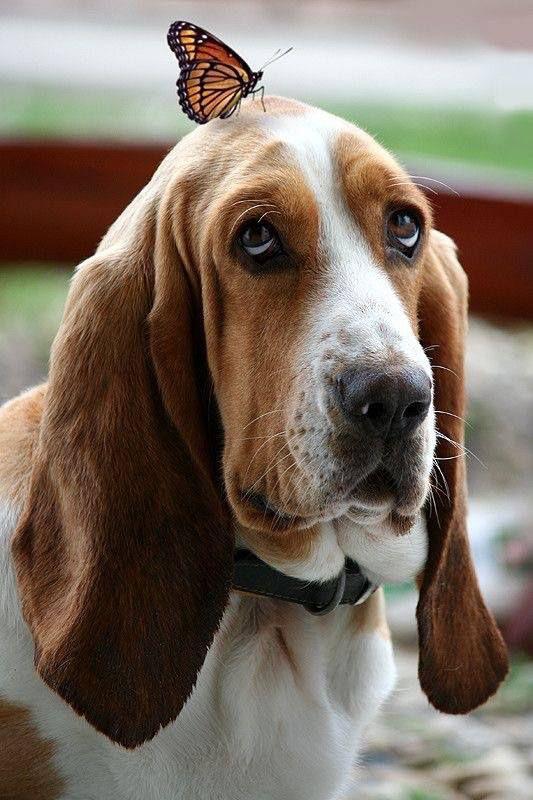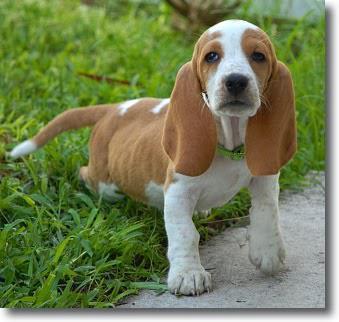The first image is the image on the left, the second image is the image on the right. Examine the images to the left and right. Is the description "The dog in the image on the right is against a white background." accurate? Answer yes or no. No. 